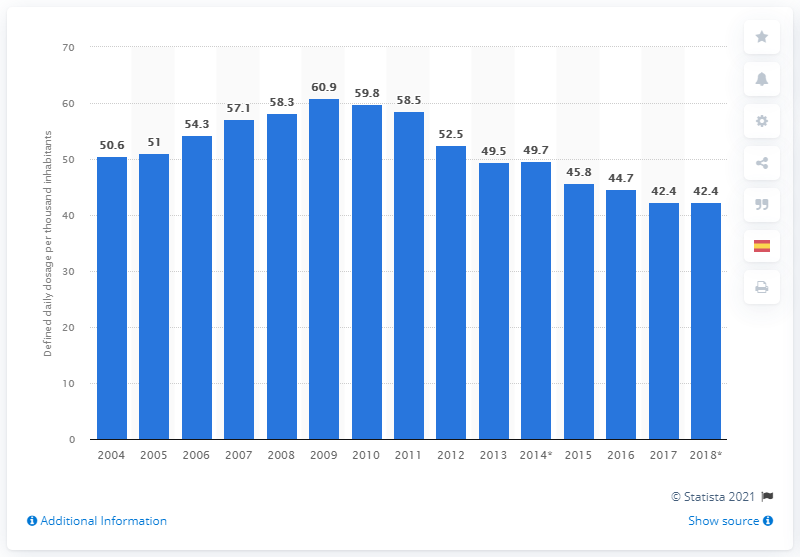Highlight a few significant elements in this photo. In 2018, the daily dose of nonsteroidal anti-inflammatory and antirheumatic preparations in Spain was 42.4. 